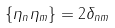Convert formula to latex. <formula><loc_0><loc_0><loc_500><loc_500>\{ \eta _ { n } \eta _ { m } \} = 2 \delta _ { n m }</formula> 